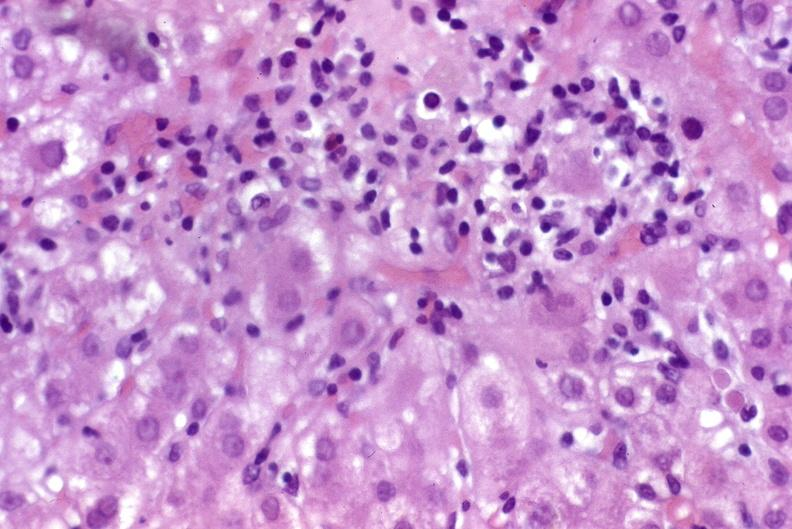s liver present?
Answer the question using a single word or phrase. Yes 